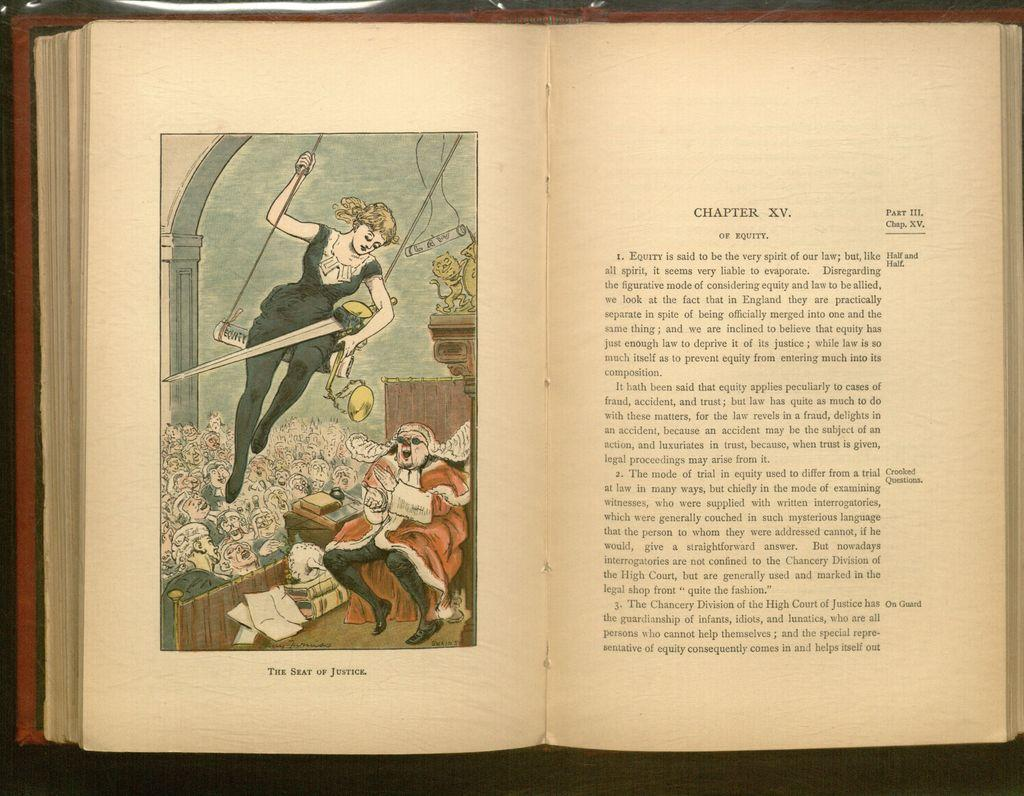<image>
Relay a brief, clear account of the picture shown. a book opened up to chapter XV of equity. 